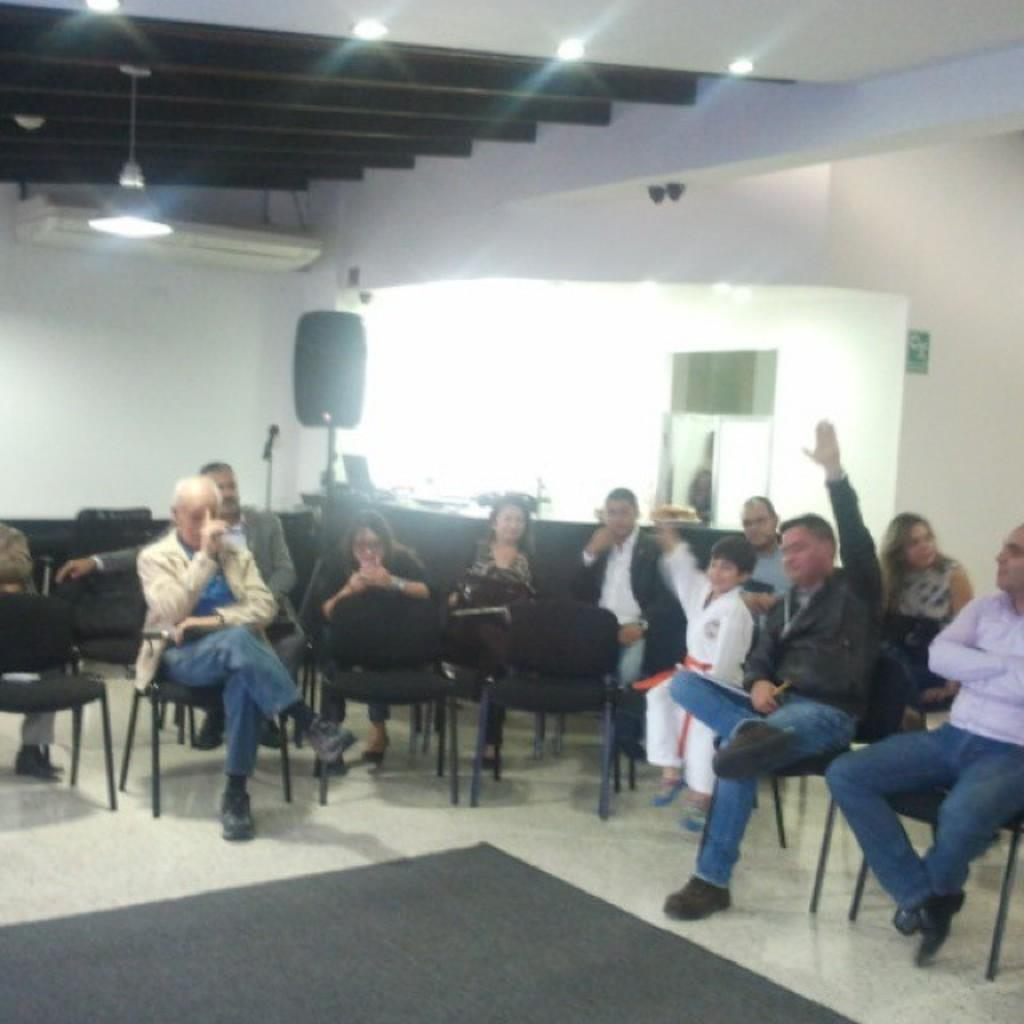What is the main subject of the image? There is a group of people in the image. What are the people doing in the image? The people are sitting on chairs. What can be seen behind the people in the image? There is a wall visible in the image. What is located at the top of the image? There are lights at the top of the image. How many beds are visible in the image? There are no beds present in the image. Is there an umbrella being used by the group of people in the image? There is no umbrella present in the image. 